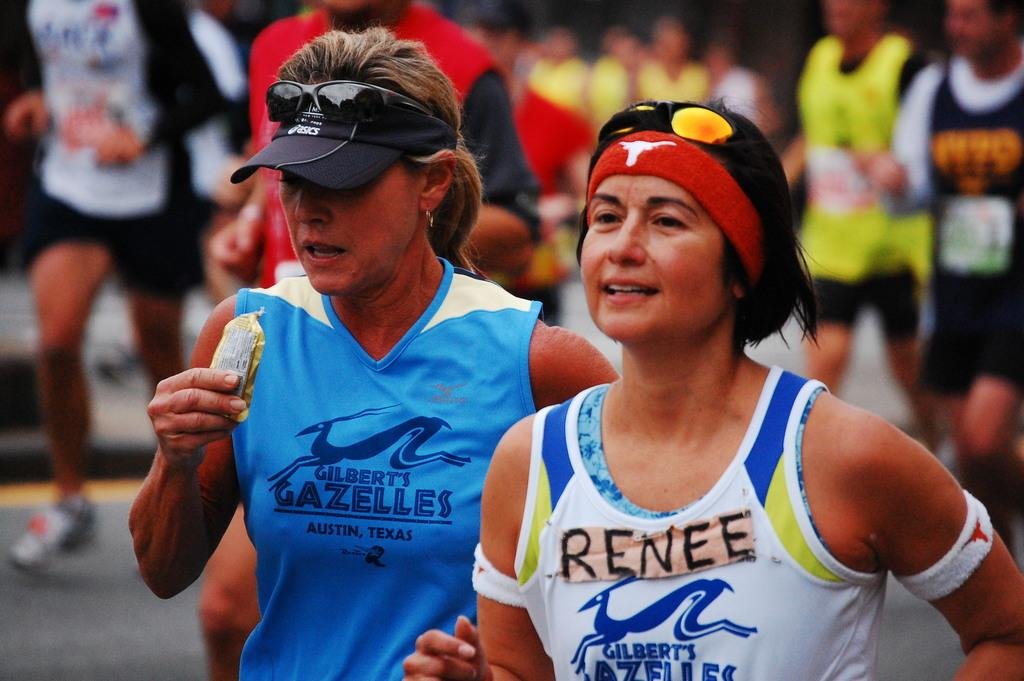Provide a one-sentence caption for the provided image. Renee and her running mates are wearing Gilbert's Gazelles top. 